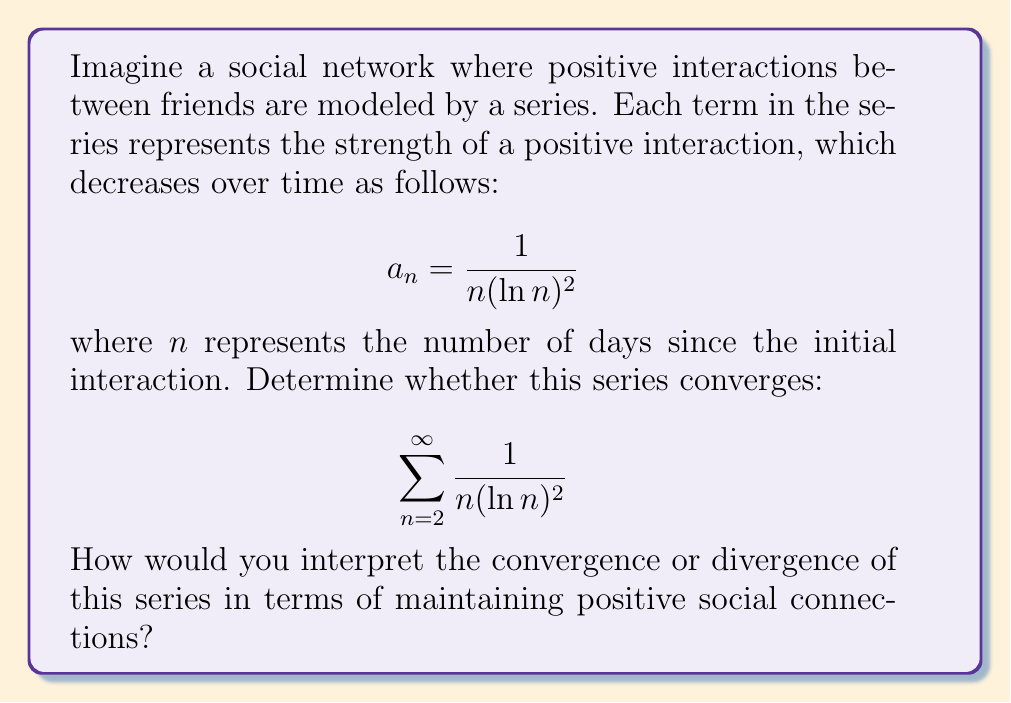Solve this math problem. To determine the convergence of this series, we can use the integral test. Let's follow these steps:

1) First, we need to verify that $f(x) = \frac{1}{x(\ln x)^2}$ is continuous, positive, and decreasing for $x \geq 2$.

   - It's continuous for $x > 1$
   - It's positive for $x > 1$
   - To check if it's decreasing, we can take the derivative:
     $$f'(x) = -\frac{1}{x^2(\ln x)^2} - \frac{2}{x^2(\ln x)^3}$$
     This is negative for $x > 1$, so $f(x)$ is decreasing.

2) Now we can apply the integral test. The series converges if and only if the following improper integral converges:

   $$\int_2^{\infty} \frac{1}{x(\ln x)^2} dx$$

3) To evaluate this integral, let $u = \ln x$. Then $du = \frac{1}{x}dx$, and our limits change:
   When $x = 2$, $u = \ln 2$
   When $x \to \infty$, $u \to \infty$

4) Substituting:

   $$\int_{\ln 2}^{\infty} \frac{1}{u^2} du$$

5) This is a standard integral:

   $$\left[-\frac{1}{u}\right]_{\ln 2}^{\infty} = \lim_{b\to\infty} \left(-\frac{1}{b} + \frac{1}{\ln 2}\right) = \frac{1}{\ln 2}$$

6) Since this limit exists and is finite, the integral converges.

Therefore, by the integral test, the series converges.

Interpreting this result in terms of social connections:
The convergence of the series suggests that while the strength of each individual positive interaction may decrease over time, the cumulative effect of these interactions remains bounded. This could be seen as encouraging, as it implies that even small, consistent positive interactions can contribute to a meaningful, stable foundation for social connections over time.
Answer: The series $\sum_{n=2}^{\infty} \frac{1}{n(\ln n)^2}$ converges. In the context of social interactions, this suggests that consistent positive interactions, even if diminishing in individual strength over time, can accumulate to form a stable and meaningful social connection. 